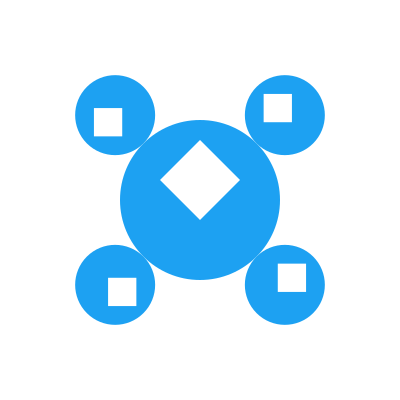As a business owner looking to promote your brand on various social media platforms, you come across this logo design. Which well-known social media platform does this logo represent, and how many rotated versions of the logo are shown in the image? To answer this question, let's break it down into steps:

1. Identify the main logo:
   - The central, larger logo features a blue circle with a white bird-like shape inside.
   - This is the iconic logo of Twitter, a popular social media platform often used by businesses for promotion and customer engagement.

2. Count the rotated versions:
   - Around the central logo, we can see four smaller, rotated versions of the same logo.
   - These rotated versions are placed at 45°, 135°, 225°, and 315° angles from the original.
   - Each rotated version is a scaled-down copy of the original logo.

3. Confirm the count:
   - We can clearly see four distinct rotated versions of the Twitter logo surrounding the central, larger logo.

4. Relevance to the persona:
   - As an entrepreneur, recognizing social media logos from various angles is crucial for effective brand promotion and understanding platform-specific marketing strategies.

Therefore, the logo represents Twitter, and there are 4 rotated versions of the logo shown in the image.
Answer: Twitter, 4 